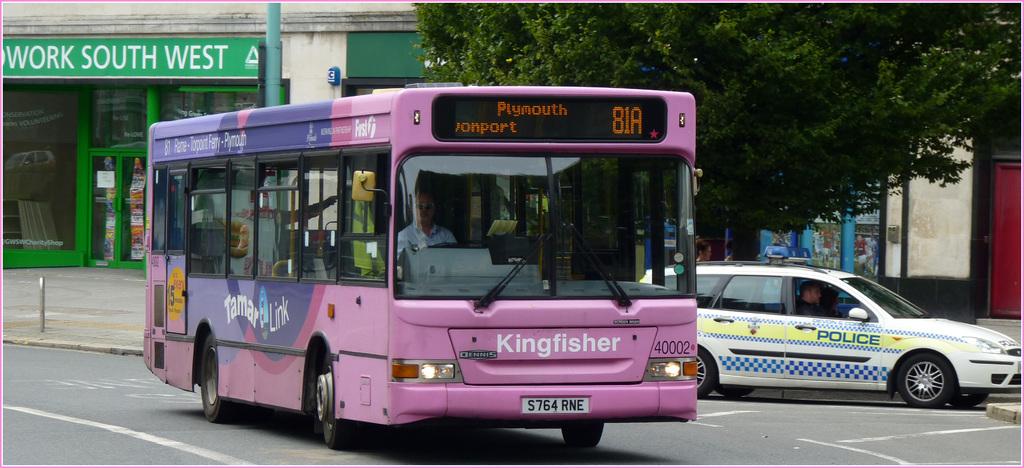What is the bus name?
Make the answer very short. Kingfisher. What is the name of the bus?
Make the answer very short. Kingfisher. 